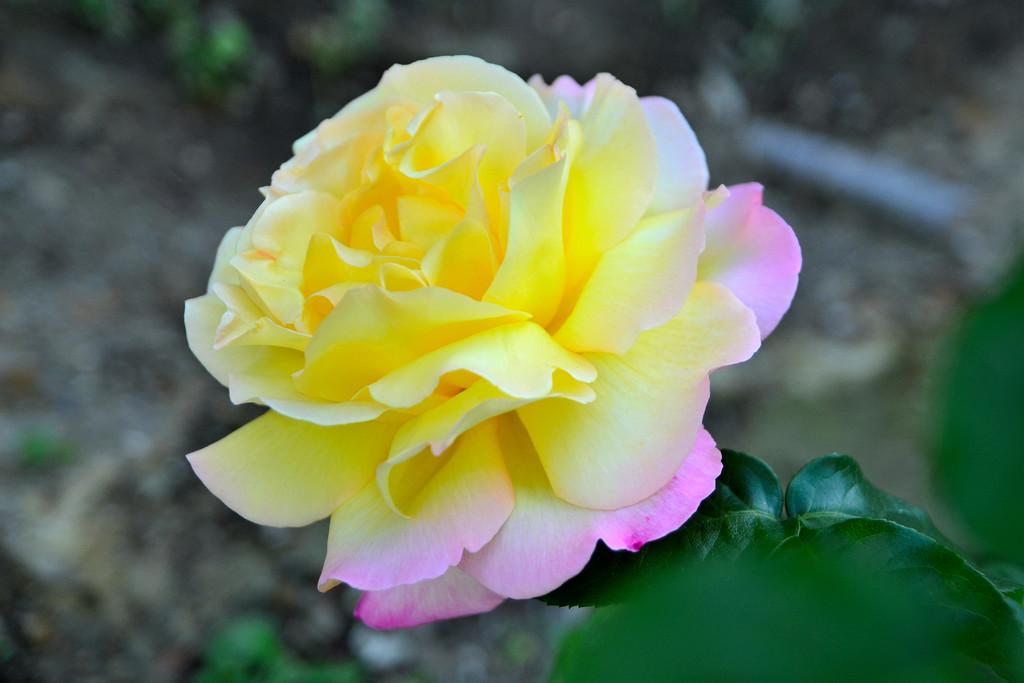What is the main subject of the image? There is a flower on a plant in the image. Can you describe the color of the flower? The flower is in yellow and pink color. What else can be seen in the background of the image? There is another plant visible in the background of the image. What is present at the bottom of the image? There is mud at the bottom of the image. How many eyes does the flower have in the image? Flowers do not have eyes, so this question cannot be answered based on the image. 